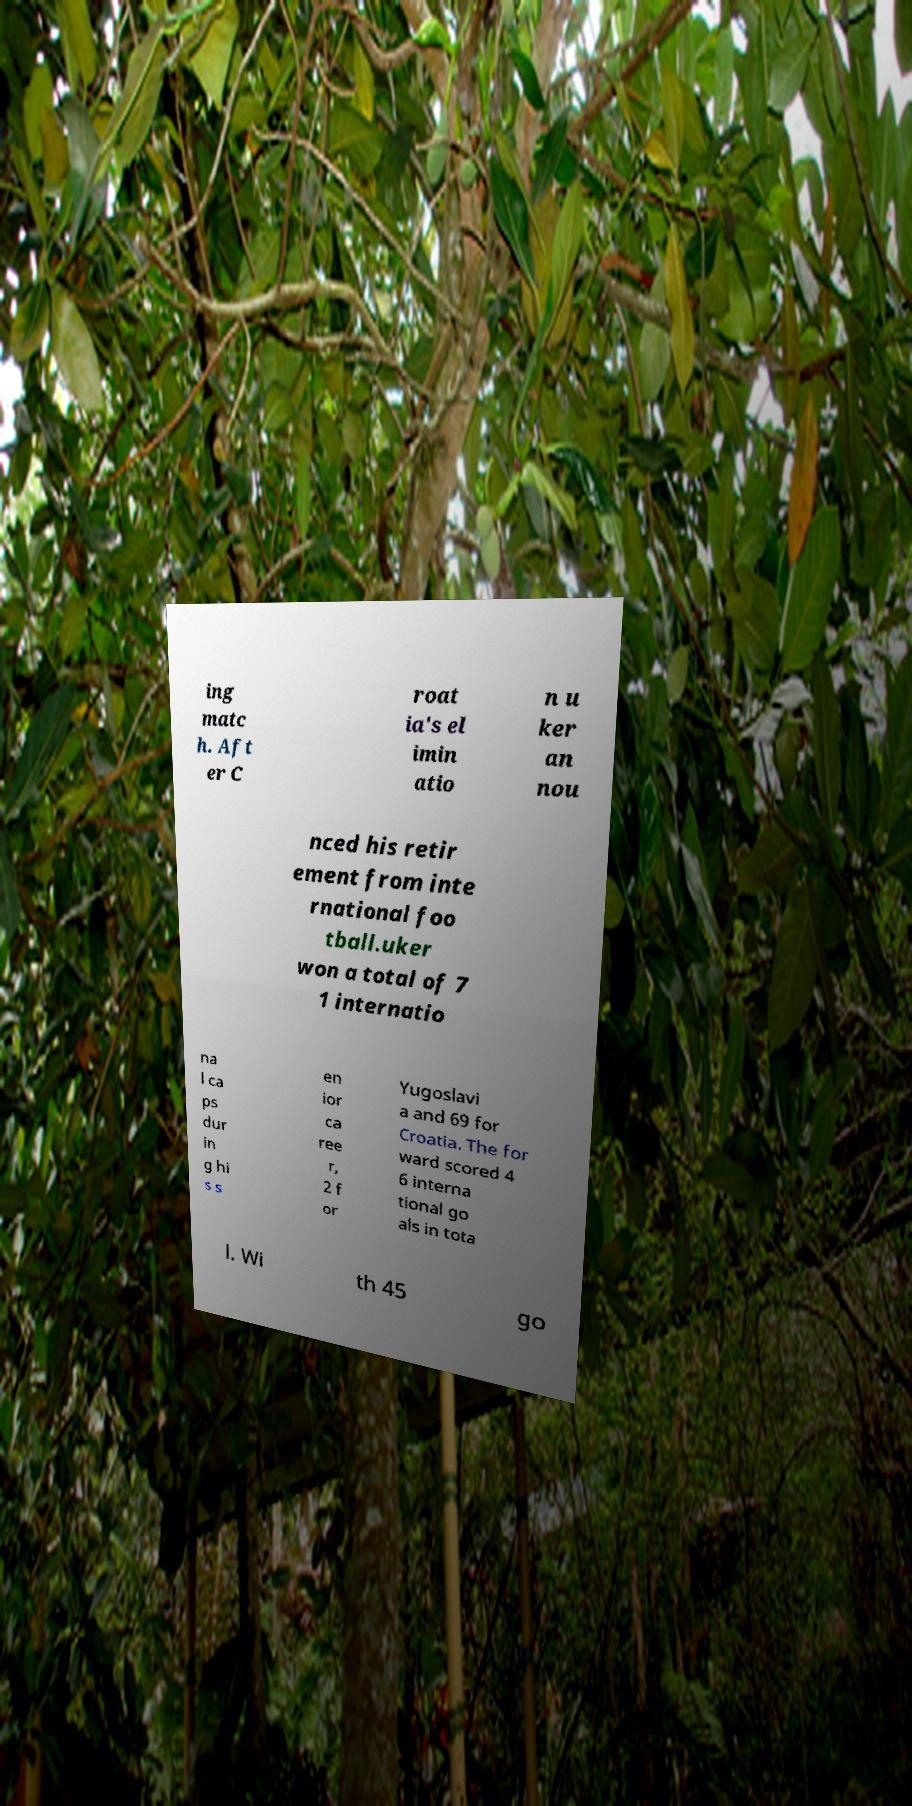Please identify and transcribe the text found in this image. ing matc h. Aft er C roat ia's el imin atio n u ker an nou nced his retir ement from inte rnational foo tball.uker won a total of 7 1 internatio na l ca ps dur in g hi s s en ior ca ree r, 2 f or Yugoslavi a and 69 for Croatia. The for ward scored 4 6 interna tional go als in tota l. Wi th 45 go 